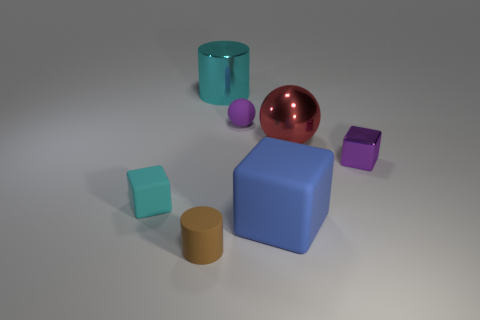Add 1 small cyan rubber objects. How many objects exist? 8 Subtract all cubes. How many objects are left? 4 Subtract all gray matte spheres. Subtract all brown matte things. How many objects are left? 6 Add 5 tiny purple matte spheres. How many tiny purple matte spheres are left? 6 Add 1 large blue matte balls. How many large blue matte balls exist? 1 Subtract 1 red balls. How many objects are left? 6 